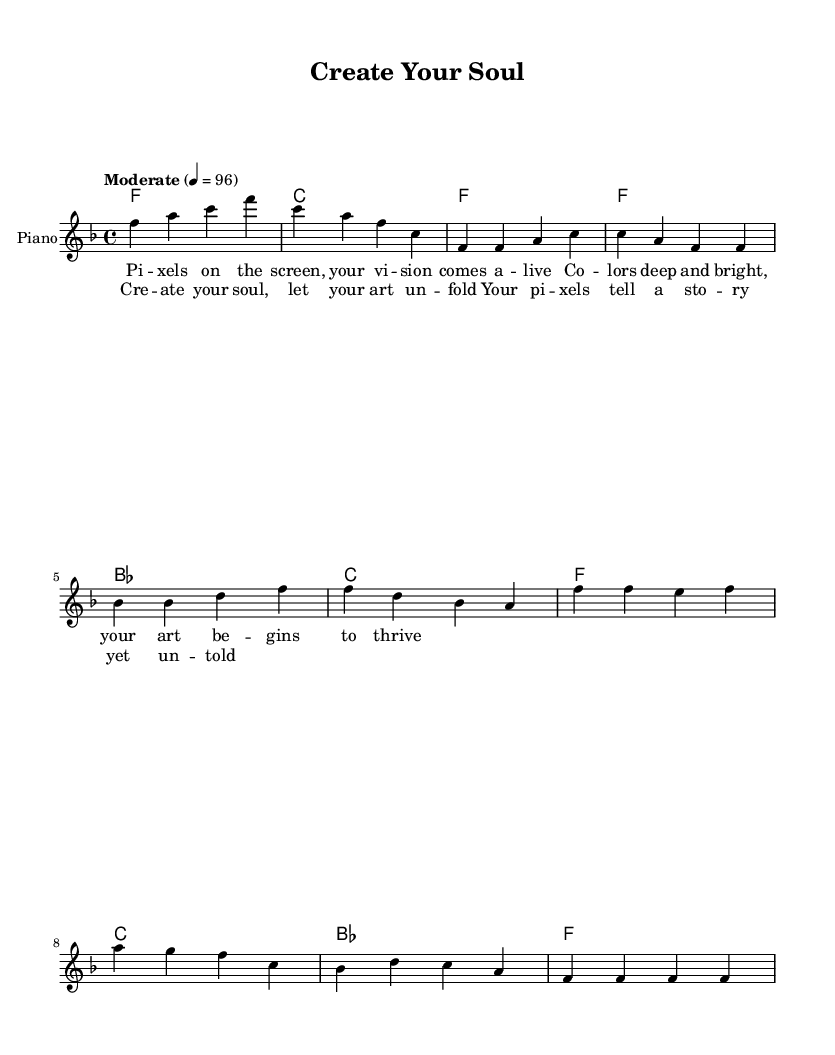What is the key signature of this music? The key signature is F major, which has one flat (B-flat).
Answer: F major What is the time signature of this music? The time signature is 4/4, which indicates four beats per measure.
Answer: 4/4 What is the tempo marking of this piece? The tempo marking is "Moderate" with a metronome marking of 96 beats per minute.
Answer: Moderate Which chords are used in the chorus? The chords in the chorus are F, C, B-flat, and F.
Answer: F, C, B-flat, F How many measures are there in the verse? The verse consists of four measures.
Answer: Four What is the main thematic element conveyed in the lyrics? The main thematic element is the empowerment and expression through pixel art.
Answer: Empowerment What stylistic aspect of soul music is represented in this piece? The piece conveys a sense of emotional depth and personal storytelling, characteristic of soul music.
Answer: Emotional depth 